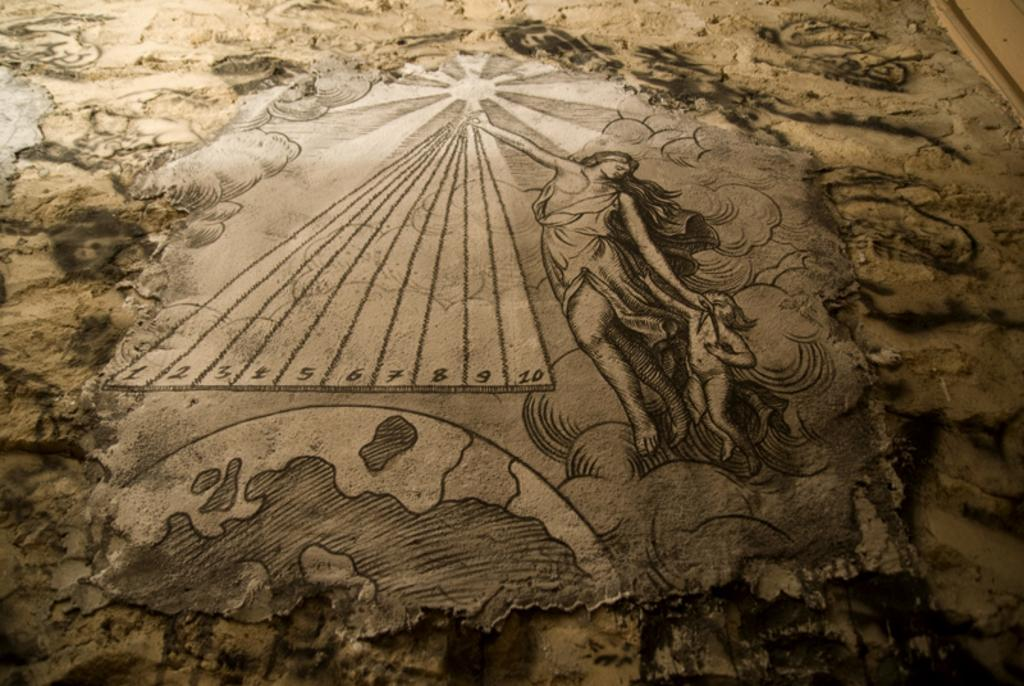What type of art is featured on the wall in the image? There is wall art in the image. What subjects are included in the wall art? The wall art includes people, a globe, numbers, and sun rays. How many clovers are depicted in the wall art? There are no clovers present in the wall art; it features people, a globe, numbers, and sun rays. What type of fowl can be seen in the wall art? There is no fowl present in the wall art; it features people, a globe, numbers, and sun rays. 